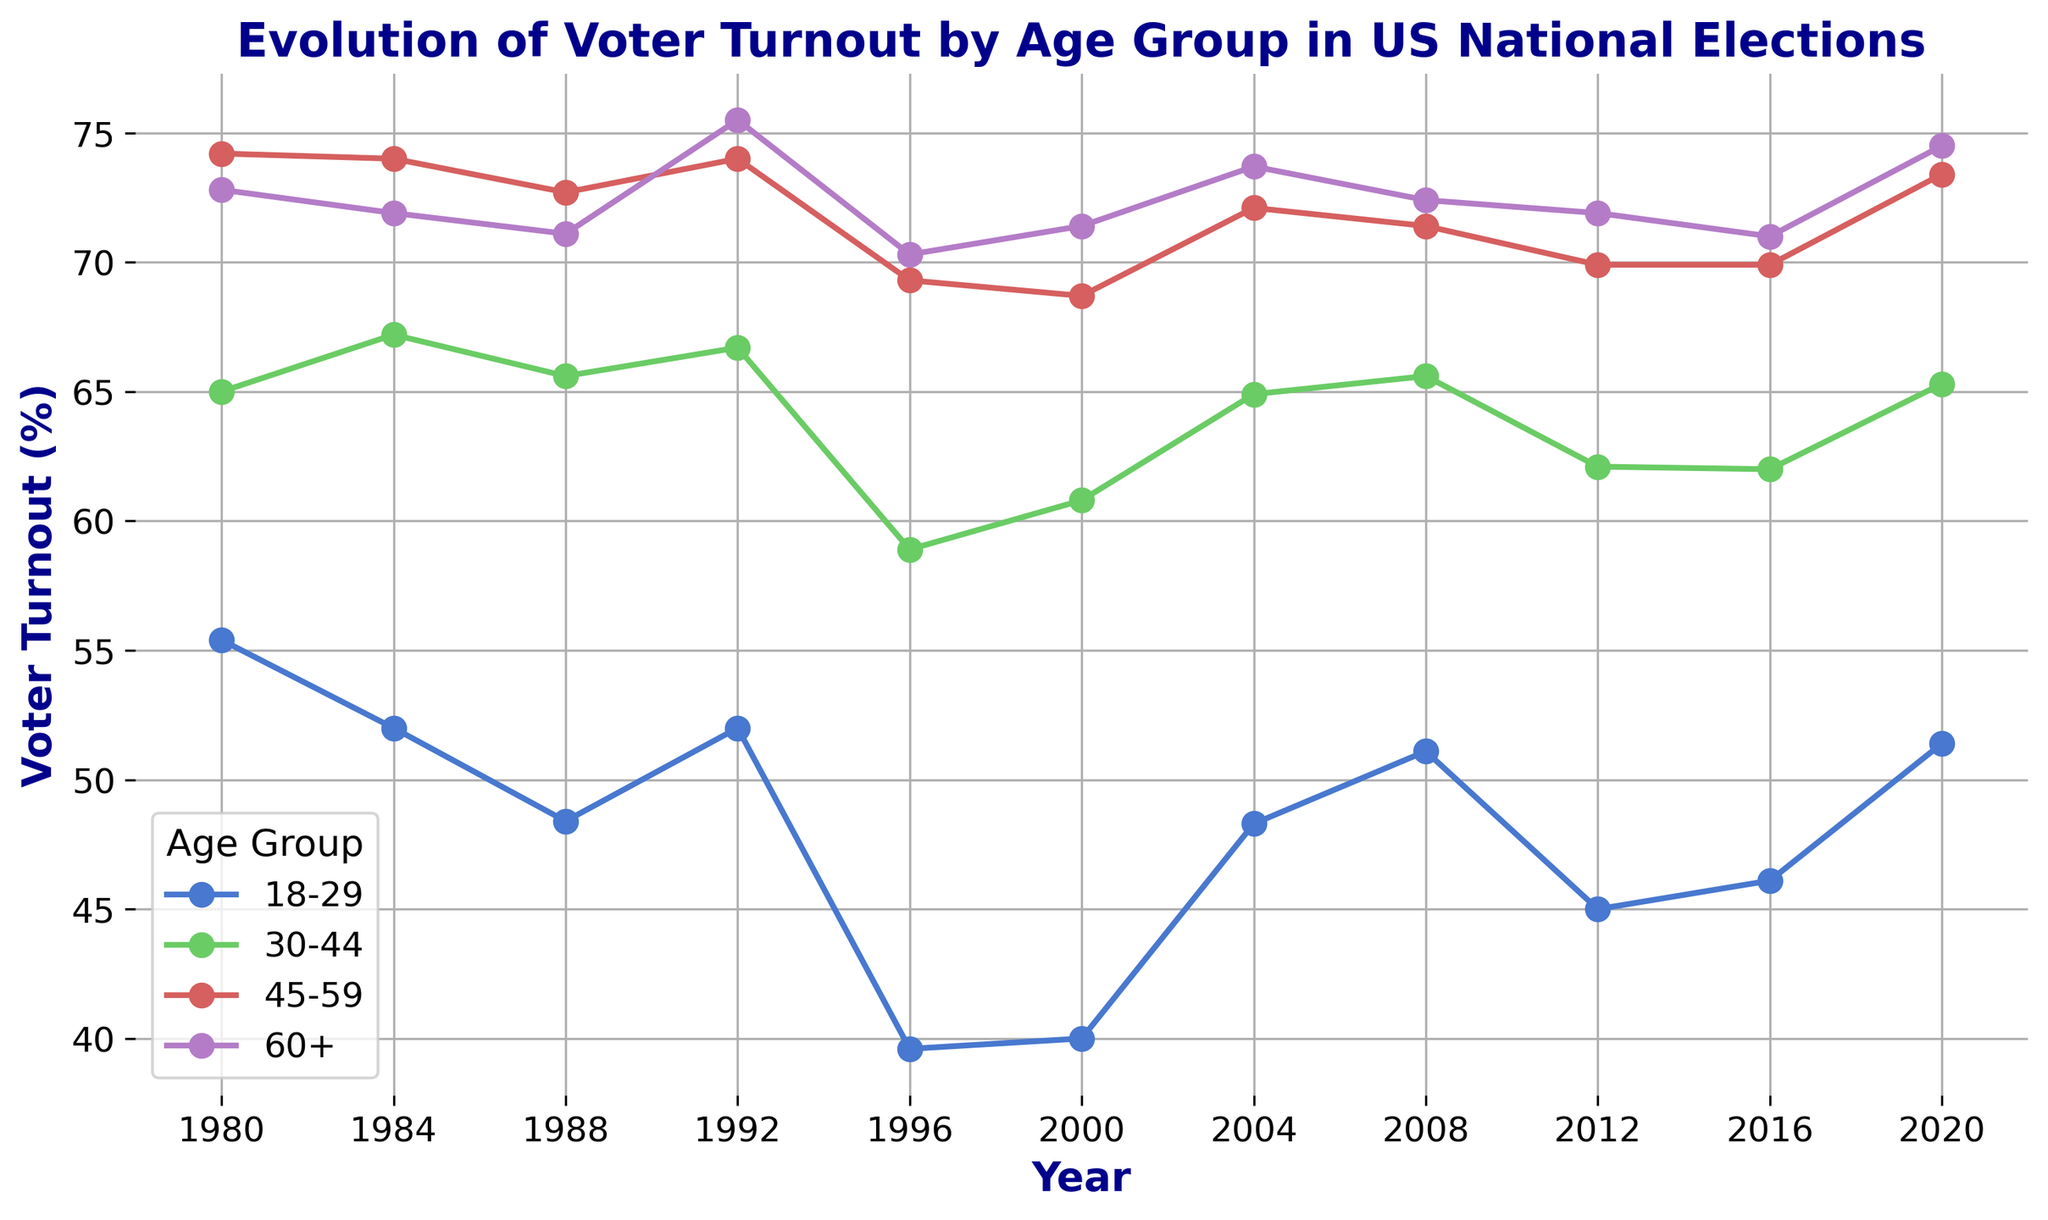Which age group had the highest voter turnout in 2020? Look at the 2020 data point for each age group in the chart and identify the highest value. The 60+ age group has the highest voter turnout at 74.5%.
Answer: 60+ Between which years did the 18-29 age group experience the largest drop in voter turnout? Examine the trend line for the 18-29 age group and identify the years with the steepest decline. The largest drop is between 1992 and 1996, where turnout dropped from 52.0% to 39.6%.
Answer: 1992-1996 Which age group consistently had the lowest voter turnout across all years? Compare the trend lines of all age groups from 1980 to 2020. The 18-29 age group had the lowest voter turnout consistently across all years.
Answer: 18-29 What is the average voter turnout for the 30-44 age group across all the years shown? Sum the voter turnout values for the 30-44 age group across all years and divide by the number of years (11). (65.0 + 67.2 + 65.6 + 66.7 + 58.9 + 60.8 + 64.9 + 65.6 + 62.1 + 62.0 + 65.3) / 11 = 64.1%.
Answer: 64.1% How many times did the voter turnout for the 45-59 age group exceed 70%? Identify the years where the voter turnout values for 45-59 age group were above 70%. These years are 1980, 1984, 1988, 1992, and 2004. So, there were 5 such occurrences.
Answer: 5 In which year did the gap in voter turnout between the 18-29 and 60+ age groups reach its maximum? Calculate the difference between the voter turnout of the 18-29 and 60+ age groups for each year, then identify the year with the maximum difference. The largest difference is in 1996, with a gap of 70.3 - 39.6 = 30.7%.
Answer: 1996 Did any age group show a decrease in voter turnout in the 2020 election compared to the 2016 election? Compare the voter turnout for all age groups between 2016 and 2020. None of the age groups showed a decrease in voter turnout; all groups either increased or remained the same.
Answer: No How does the voter turnout in 2004 for the 30-44 age group compare to the 60+ age group? Look at the voter turnout values for both the 30-44 and 60+ age groups in 2004. The 30-44 age group had 64.9% while the 60+ age group had 73.7%. The turnout for the 60+ group was higher.
Answer: 60+ higher 